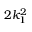<formula> <loc_0><loc_0><loc_500><loc_500>2 k _ { 1 } ^ { 2 }</formula> 